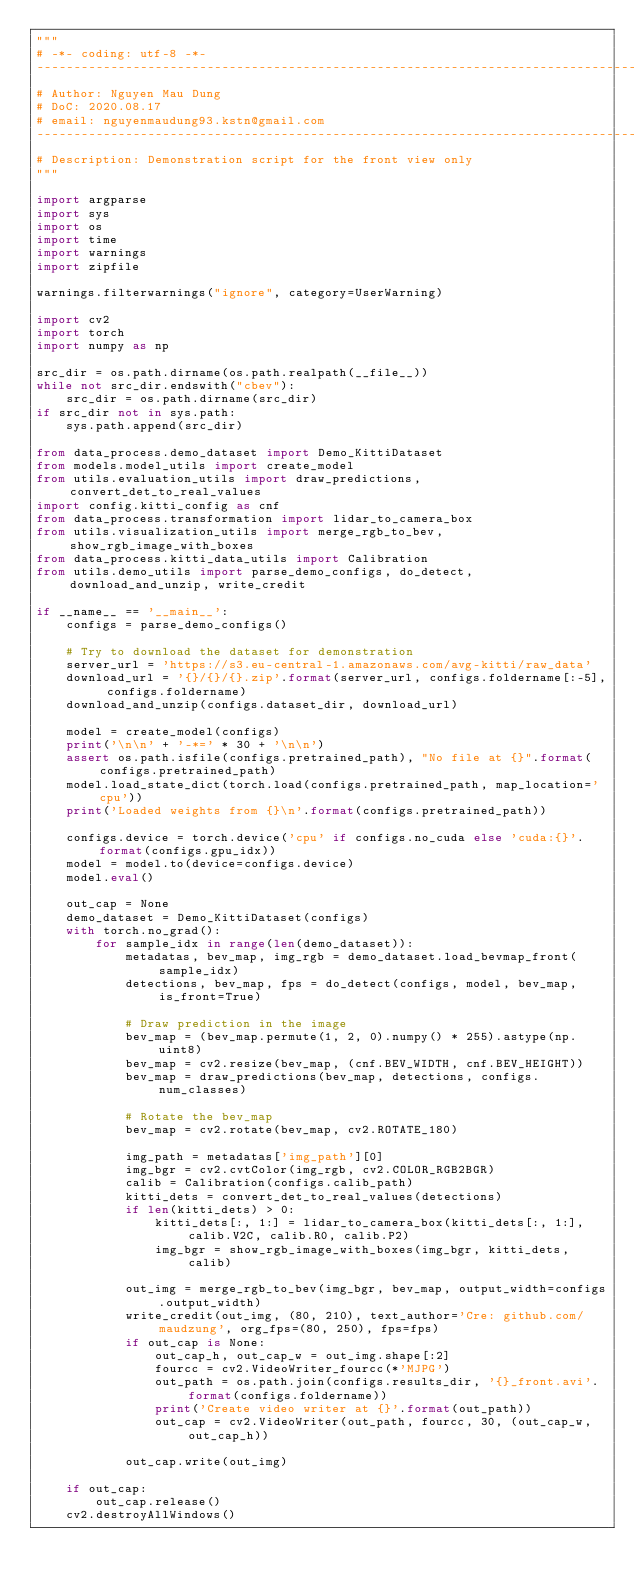<code> <loc_0><loc_0><loc_500><loc_500><_Python_>"""
# -*- coding: utf-8 -*-
-----------------------------------------------------------------------------------
# Author: Nguyen Mau Dung
# DoC: 2020.08.17
# email: nguyenmaudung93.kstn@gmail.com
-----------------------------------------------------------------------------------
# Description: Demonstration script for the front view only
"""

import argparse
import sys
import os
import time
import warnings
import zipfile

warnings.filterwarnings("ignore", category=UserWarning)

import cv2
import torch
import numpy as np

src_dir = os.path.dirname(os.path.realpath(__file__))
while not src_dir.endswith("cbev"):
    src_dir = os.path.dirname(src_dir)
if src_dir not in sys.path:
    sys.path.append(src_dir)

from data_process.demo_dataset import Demo_KittiDataset
from models.model_utils import create_model
from utils.evaluation_utils import draw_predictions, convert_det_to_real_values
import config.kitti_config as cnf
from data_process.transformation import lidar_to_camera_box
from utils.visualization_utils import merge_rgb_to_bev, show_rgb_image_with_boxes
from data_process.kitti_data_utils import Calibration
from utils.demo_utils import parse_demo_configs, do_detect, download_and_unzip, write_credit

if __name__ == '__main__':
    configs = parse_demo_configs()

    # Try to download the dataset for demonstration
    server_url = 'https://s3.eu-central-1.amazonaws.com/avg-kitti/raw_data'
    download_url = '{}/{}/{}.zip'.format(server_url, configs.foldername[:-5], configs.foldername)
    download_and_unzip(configs.dataset_dir, download_url)

    model = create_model(configs)
    print('\n\n' + '-*=' * 30 + '\n\n')
    assert os.path.isfile(configs.pretrained_path), "No file at {}".format(configs.pretrained_path)
    model.load_state_dict(torch.load(configs.pretrained_path, map_location='cpu'))
    print('Loaded weights from {}\n'.format(configs.pretrained_path))

    configs.device = torch.device('cpu' if configs.no_cuda else 'cuda:{}'.format(configs.gpu_idx))
    model = model.to(device=configs.device)
    model.eval()

    out_cap = None
    demo_dataset = Demo_KittiDataset(configs)
    with torch.no_grad():
        for sample_idx in range(len(demo_dataset)):
            metadatas, bev_map, img_rgb = demo_dataset.load_bevmap_front(sample_idx)
            detections, bev_map, fps = do_detect(configs, model, bev_map, is_front=True)

            # Draw prediction in the image
            bev_map = (bev_map.permute(1, 2, 0).numpy() * 255).astype(np.uint8)
            bev_map = cv2.resize(bev_map, (cnf.BEV_WIDTH, cnf.BEV_HEIGHT))
            bev_map = draw_predictions(bev_map, detections, configs.num_classes)

            # Rotate the bev_map
            bev_map = cv2.rotate(bev_map, cv2.ROTATE_180)

            img_path = metadatas['img_path'][0]
            img_bgr = cv2.cvtColor(img_rgb, cv2.COLOR_RGB2BGR)
            calib = Calibration(configs.calib_path)
            kitti_dets = convert_det_to_real_values(detections)
            if len(kitti_dets) > 0:
                kitti_dets[:, 1:] = lidar_to_camera_box(kitti_dets[:, 1:], calib.V2C, calib.R0, calib.P2)
                img_bgr = show_rgb_image_with_boxes(img_bgr, kitti_dets, calib)

            out_img = merge_rgb_to_bev(img_bgr, bev_map, output_width=configs.output_width)
            write_credit(out_img, (80, 210), text_author='Cre: github.com/maudzung', org_fps=(80, 250), fps=fps)
            if out_cap is None:
                out_cap_h, out_cap_w = out_img.shape[:2]
                fourcc = cv2.VideoWriter_fourcc(*'MJPG')
                out_path = os.path.join(configs.results_dir, '{}_front.avi'.format(configs.foldername))
                print('Create video writer at {}'.format(out_path))
                out_cap = cv2.VideoWriter(out_path, fourcc, 30, (out_cap_w, out_cap_h))

            out_cap.write(out_img)

    if out_cap:
        out_cap.release()
    cv2.destroyAllWindows()
</code> 